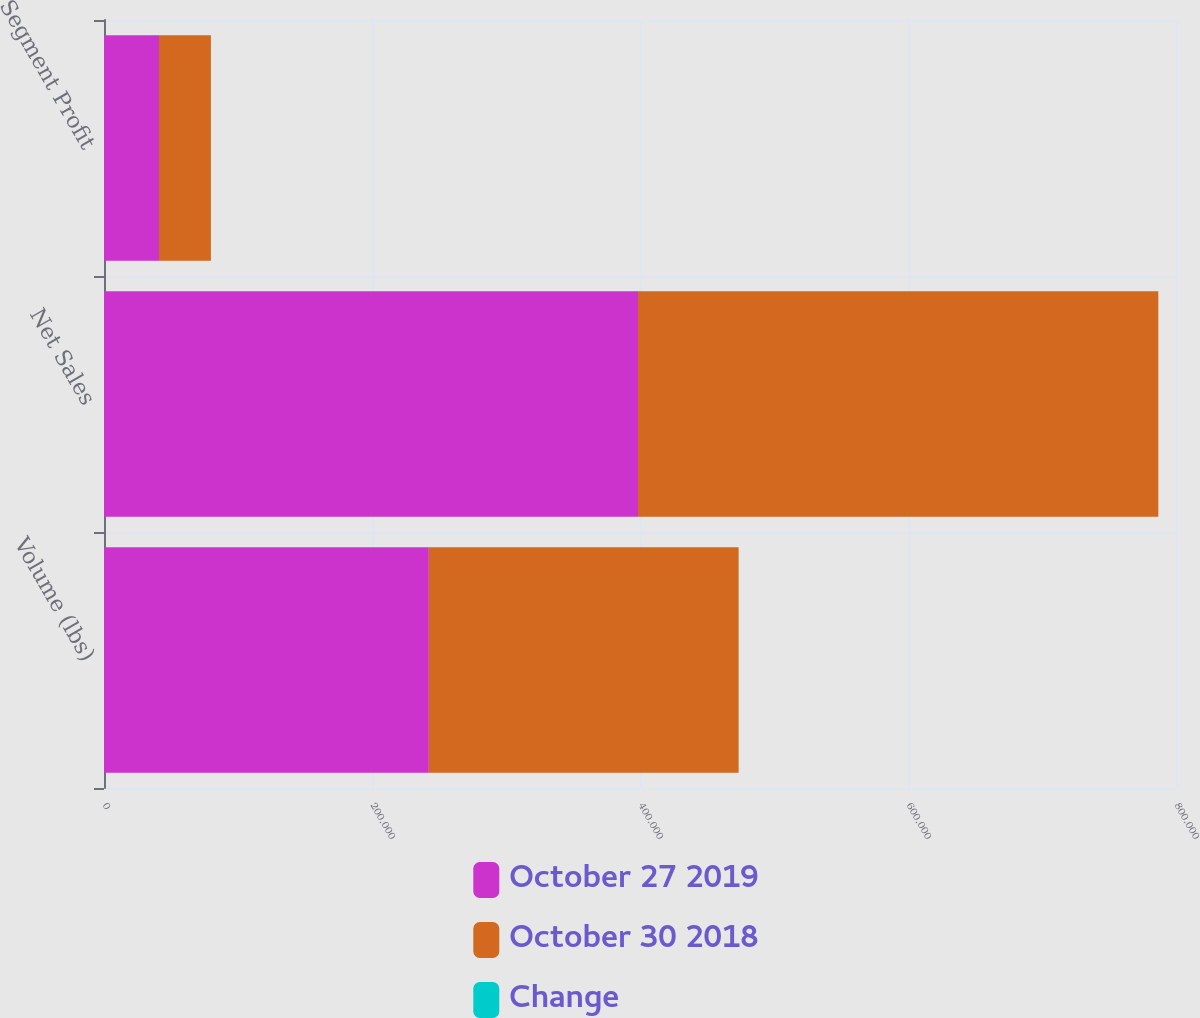Convert chart. <chart><loc_0><loc_0><loc_500><loc_500><stacked_bar_chart><ecel><fcel>Volume (lbs)<fcel>Net Sales<fcel>Segment Profit<nl><fcel>October 27 2019<fcel>242421<fcel>398512<fcel>41031<nl><fcel>October 30 2018<fcel>231180<fcel>388278<fcel>38744<nl><fcel>Change<fcel>4.9<fcel>2.6<fcel>5.9<nl></chart> 